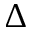Convert formula to latex. <formula><loc_0><loc_0><loc_500><loc_500>\Delta</formula> 